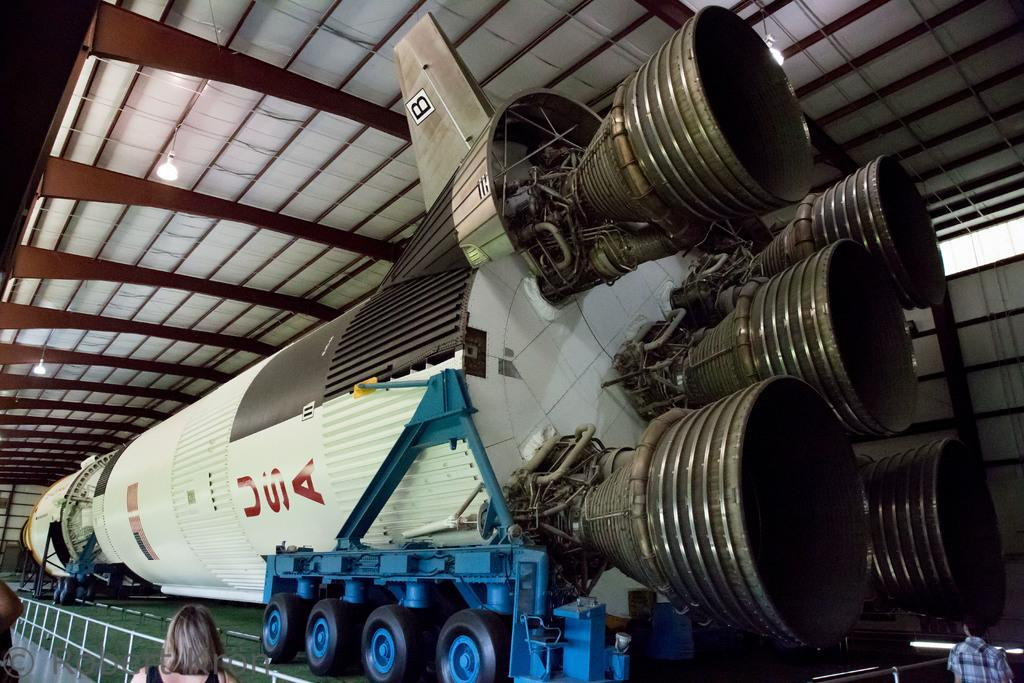<image>
Create a compact narrative representing the image presented. A rocket with USA on it sits ready to launch 